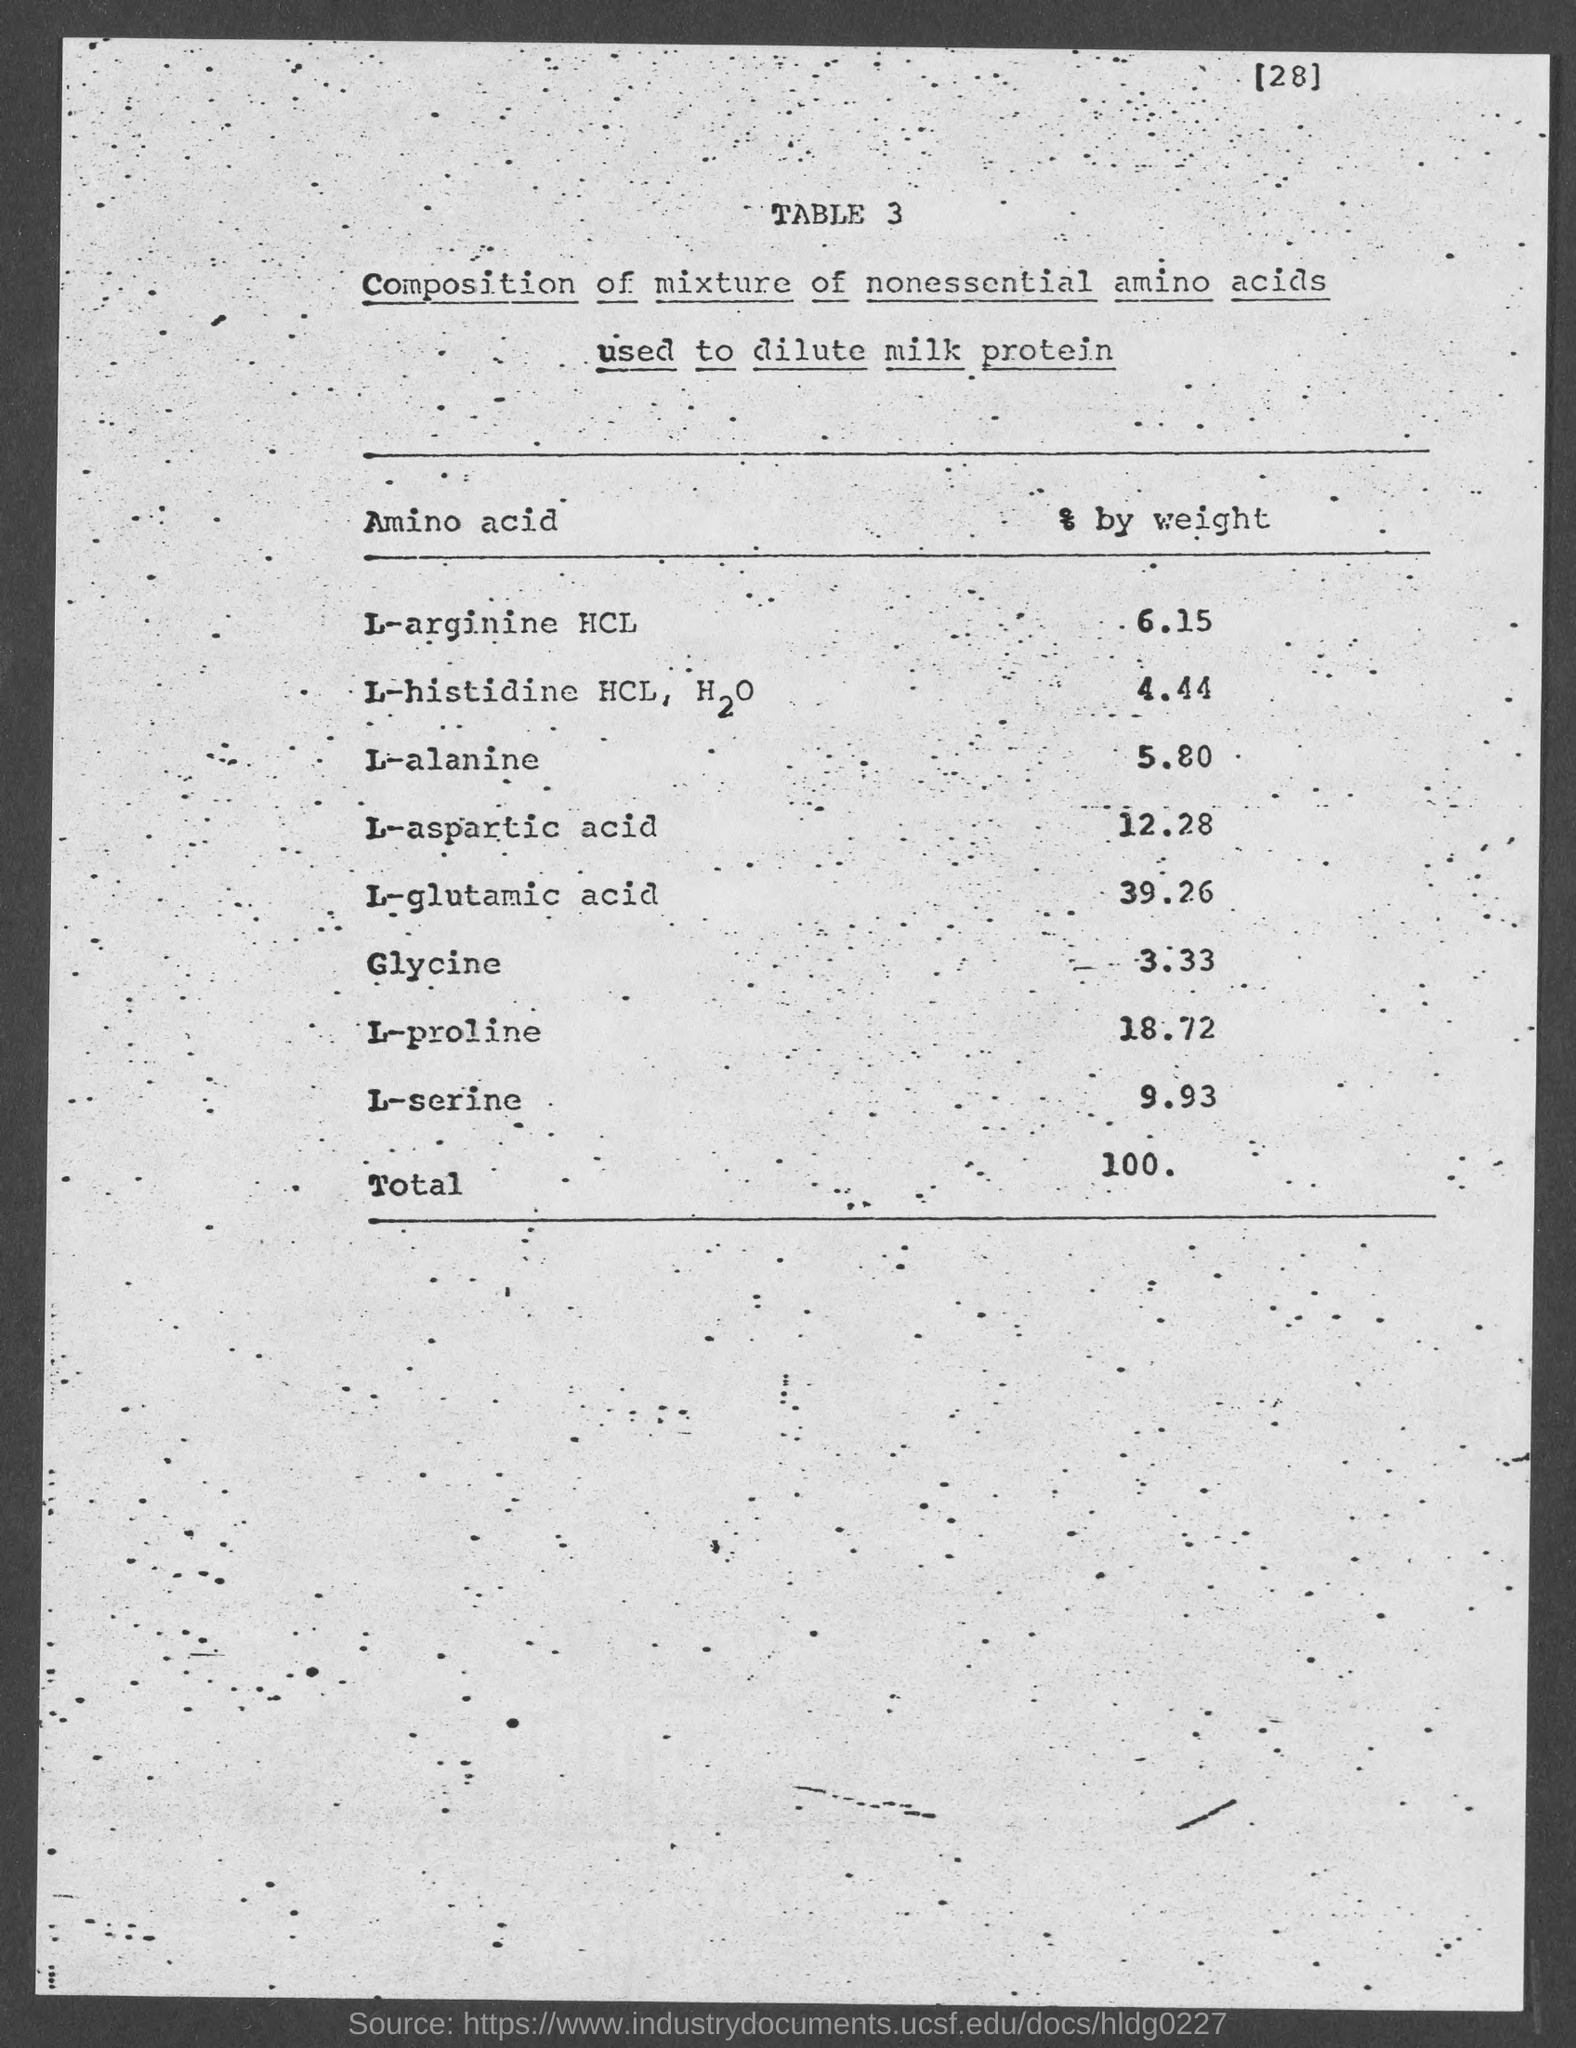What is the table number?
Offer a terse response. Table 3. What is the page number?
Give a very brief answer. 28. What is the total weight?
Give a very brief answer. 100. What is the title of the first column of the table?
Your response must be concise. Amino acid. What is the title of the second column of the table?
Offer a terse response. % by weight. What is the percentage of glycine in the mixture?
Ensure brevity in your answer.  3.33. What is the percentage of L-alanine in the mixture?
Make the answer very short. 5.80. Which amino acid is present in a large amount in the mixture?
Provide a short and direct response. L-glutamic acid. Which amino acid is present in a small amount in the mixture?
Give a very brief answer. Glycine. 